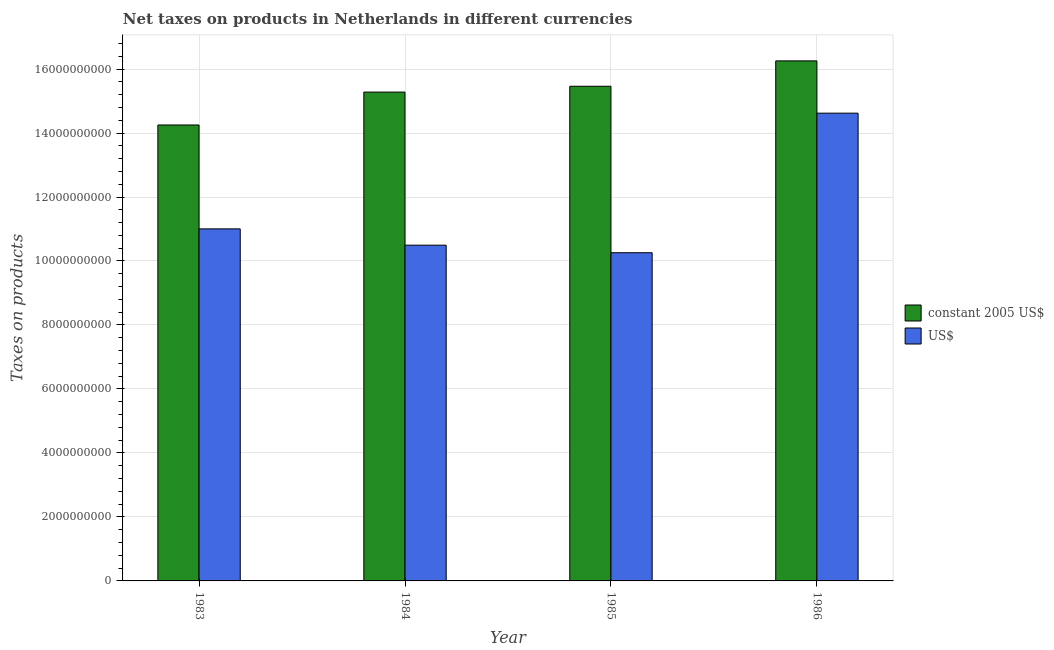How many different coloured bars are there?
Provide a short and direct response. 2. Are the number of bars per tick equal to the number of legend labels?
Your answer should be compact. Yes. What is the net taxes in constant 2005 us$ in 1985?
Offer a terse response. 1.55e+1. Across all years, what is the maximum net taxes in us$?
Your answer should be very brief. 1.46e+1. Across all years, what is the minimum net taxes in us$?
Provide a succinct answer. 1.03e+1. In which year was the net taxes in us$ minimum?
Keep it short and to the point. 1985. What is the total net taxes in constant 2005 us$ in the graph?
Offer a terse response. 6.12e+1. What is the difference between the net taxes in constant 2005 us$ in 1983 and that in 1985?
Give a very brief answer. -1.21e+09. What is the difference between the net taxes in us$ in 1984 and the net taxes in constant 2005 us$ in 1985?
Ensure brevity in your answer.  2.36e+08. What is the average net taxes in us$ per year?
Offer a terse response. 1.16e+1. In the year 1983, what is the difference between the net taxes in constant 2005 us$ and net taxes in us$?
Offer a very short reply. 0. In how many years, is the net taxes in us$ greater than 4000000000 units?
Keep it short and to the point. 4. What is the ratio of the net taxes in constant 2005 us$ in 1985 to that in 1986?
Give a very brief answer. 0.95. Is the net taxes in us$ in 1984 less than that in 1986?
Your response must be concise. Yes. Is the difference between the net taxes in us$ in 1984 and 1985 greater than the difference between the net taxes in constant 2005 us$ in 1984 and 1985?
Ensure brevity in your answer.  No. What is the difference between the highest and the second highest net taxes in us$?
Your response must be concise. 3.62e+09. What is the difference between the highest and the lowest net taxes in us$?
Ensure brevity in your answer.  4.36e+09. In how many years, is the net taxes in us$ greater than the average net taxes in us$ taken over all years?
Your response must be concise. 1. What does the 2nd bar from the left in 1983 represents?
Ensure brevity in your answer.  US$. What does the 2nd bar from the right in 1985 represents?
Your response must be concise. Constant 2005 us$. How many bars are there?
Your response must be concise. 8. Are all the bars in the graph horizontal?
Give a very brief answer. No. What is the difference between two consecutive major ticks on the Y-axis?
Your answer should be compact. 2.00e+09. Are the values on the major ticks of Y-axis written in scientific E-notation?
Your answer should be very brief. No. Does the graph contain any zero values?
Offer a very short reply. No. Where does the legend appear in the graph?
Offer a terse response. Center right. What is the title of the graph?
Offer a very short reply. Net taxes on products in Netherlands in different currencies. What is the label or title of the Y-axis?
Offer a very short reply. Taxes on products. What is the Taxes on products of constant 2005 US$ in 1983?
Make the answer very short. 1.43e+1. What is the Taxes on products in US$ in 1983?
Provide a short and direct response. 1.10e+1. What is the Taxes on products in constant 2005 US$ in 1984?
Provide a short and direct response. 1.53e+1. What is the Taxes on products of US$ in 1984?
Offer a terse response. 1.05e+1. What is the Taxes on products of constant 2005 US$ in 1985?
Offer a very short reply. 1.55e+1. What is the Taxes on products in US$ in 1985?
Ensure brevity in your answer.  1.03e+1. What is the Taxes on products in constant 2005 US$ in 1986?
Ensure brevity in your answer.  1.63e+1. What is the Taxes on products in US$ in 1986?
Offer a very short reply. 1.46e+1. Across all years, what is the maximum Taxes on products in constant 2005 US$?
Make the answer very short. 1.63e+1. Across all years, what is the maximum Taxes on products of US$?
Give a very brief answer. 1.46e+1. Across all years, what is the minimum Taxes on products in constant 2005 US$?
Offer a terse response. 1.43e+1. Across all years, what is the minimum Taxes on products in US$?
Your answer should be compact. 1.03e+1. What is the total Taxes on products of constant 2005 US$ in the graph?
Make the answer very short. 6.12e+1. What is the total Taxes on products of US$ in the graph?
Offer a terse response. 4.64e+1. What is the difference between the Taxes on products of constant 2005 US$ in 1983 and that in 1984?
Your answer should be compact. -1.03e+09. What is the difference between the Taxes on products of US$ in 1983 and that in 1984?
Offer a terse response. 5.10e+08. What is the difference between the Taxes on products of constant 2005 US$ in 1983 and that in 1985?
Offer a terse response. -1.21e+09. What is the difference between the Taxes on products in US$ in 1983 and that in 1985?
Your answer should be very brief. 7.45e+08. What is the difference between the Taxes on products in constant 2005 US$ in 1983 and that in 1986?
Your response must be concise. -2.00e+09. What is the difference between the Taxes on products in US$ in 1983 and that in 1986?
Provide a short and direct response. -3.62e+09. What is the difference between the Taxes on products of constant 2005 US$ in 1984 and that in 1985?
Give a very brief answer. -1.82e+08. What is the difference between the Taxes on products in US$ in 1984 and that in 1985?
Your answer should be compact. 2.36e+08. What is the difference between the Taxes on products of constant 2005 US$ in 1984 and that in 1986?
Offer a very short reply. -9.76e+08. What is the difference between the Taxes on products in US$ in 1984 and that in 1986?
Your answer should be compact. -4.13e+09. What is the difference between the Taxes on products in constant 2005 US$ in 1985 and that in 1986?
Keep it short and to the point. -7.93e+08. What is the difference between the Taxes on products of US$ in 1985 and that in 1986?
Your answer should be very brief. -4.36e+09. What is the difference between the Taxes on products of constant 2005 US$ in 1983 and the Taxes on products of US$ in 1984?
Make the answer very short. 3.76e+09. What is the difference between the Taxes on products in constant 2005 US$ in 1983 and the Taxes on products in US$ in 1985?
Give a very brief answer. 3.99e+09. What is the difference between the Taxes on products of constant 2005 US$ in 1983 and the Taxes on products of US$ in 1986?
Offer a very short reply. -3.69e+08. What is the difference between the Taxes on products of constant 2005 US$ in 1984 and the Taxes on products of US$ in 1985?
Keep it short and to the point. 5.02e+09. What is the difference between the Taxes on products of constant 2005 US$ in 1984 and the Taxes on products of US$ in 1986?
Your answer should be very brief. 6.59e+08. What is the difference between the Taxes on products in constant 2005 US$ in 1985 and the Taxes on products in US$ in 1986?
Provide a short and direct response. 8.41e+08. What is the average Taxes on products of constant 2005 US$ per year?
Offer a terse response. 1.53e+1. What is the average Taxes on products of US$ per year?
Ensure brevity in your answer.  1.16e+1. In the year 1983, what is the difference between the Taxes on products of constant 2005 US$ and Taxes on products of US$?
Your answer should be very brief. 3.25e+09. In the year 1984, what is the difference between the Taxes on products in constant 2005 US$ and Taxes on products in US$?
Provide a short and direct response. 4.79e+09. In the year 1985, what is the difference between the Taxes on products of constant 2005 US$ and Taxes on products of US$?
Make the answer very short. 5.20e+09. In the year 1986, what is the difference between the Taxes on products in constant 2005 US$ and Taxes on products in US$?
Keep it short and to the point. 1.63e+09. What is the ratio of the Taxes on products in constant 2005 US$ in 1983 to that in 1984?
Provide a succinct answer. 0.93. What is the ratio of the Taxes on products in US$ in 1983 to that in 1984?
Keep it short and to the point. 1.05. What is the ratio of the Taxes on products of constant 2005 US$ in 1983 to that in 1985?
Ensure brevity in your answer.  0.92. What is the ratio of the Taxes on products of US$ in 1983 to that in 1985?
Offer a terse response. 1.07. What is the ratio of the Taxes on products in constant 2005 US$ in 1983 to that in 1986?
Ensure brevity in your answer.  0.88. What is the ratio of the Taxes on products of US$ in 1983 to that in 1986?
Your answer should be compact. 0.75. What is the ratio of the Taxes on products in constant 2005 US$ in 1984 to that in 1985?
Your response must be concise. 0.99. What is the ratio of the Taxes on products of US$ in 1984 to that in 1986?
Your response must be concise. 0.72. What is the ratio of the Taxes on products of constant 2005 US$ in 1985 to that in 1986?
Your response must be concise. 0.95. What is the ratio of the Taxes on products of US$ in 1985 to that in 1986?
Ensure brevity in your answer.  0.7. What is the difference between the highest and the second highest Taxes on products of constant 2005 US$?
Your answer should be compact. 7.93e+08. What is the difference between the highest and the second highest Taxes on products in US$?
Keep it short and to the point. 3.62e+09. What is the difference between the highest and the lowest Taxes on products of constant 2005 US$?
Your answer should be very brief. 2.00e+09. What is the difference between the highest and the lowest Taxes on products of US$?
Your answer should be very brief. 4.36e+09. 